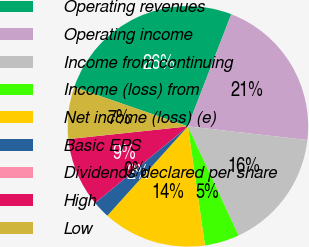Convert chart to OTSL. <chart><loc_0><loc_0><loc_500><loc_500><pie_chart><fcel>Operating revenues<fcel>Operating income<fcel>Income from continuing<fcel>Income (loss) from<fcel>Net income (loss) (e)<fcel>Basic EPS<fcel>Dividends declared per share<fcel>High<fcel>Low<nl><fcel>25.58%<fcel>20.93%<fcel>16.28%<fcel>4.65%<fcel>13.95%<fcel>2.33%<fcel>0.0%<fcel>9.3%<fcel>6.98%<nl></chart> 